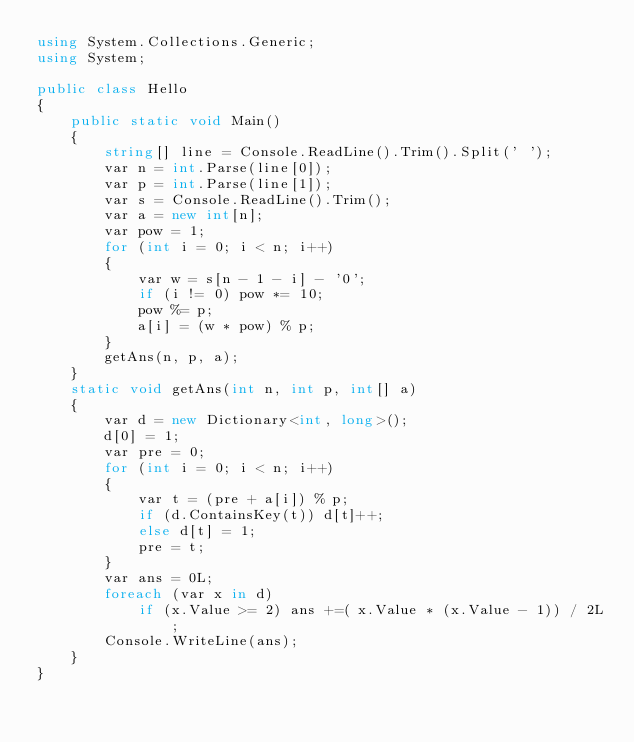Convert code to text. <code><loc_0><loc_0><loc_500><loc_500><_C#_>using System.Collections.Generic;
using System;

public class Hello
{
    public static void Main()
    {
        string[] line = Console.ReadLine().Trim().Split(' ');
        var n = int.Parse(line[0]);
        var p = int.Parse(line[1]);
        var s = Console.ReadLine().Trim();
        var a = new int[n];
        var pow = 1;
        for (int i = 0; i < n; i++)
        {
            var w = s[n - 1 - i] - '0';
            if (i != 0) pow *= 10;
            pow %= p;
            a[i] = (w * pow) % p;
        }
        getAns(n, p, a);
    }
    static void getAns(int n, int p, int[] a)
    {
        var d = new Dictionary<int, long>();
        d[0] = 1;
        var pre = 0;
        for (int i = 0; i < n; i++)
        {
            var t = (pre + a[i]) % p;
            if (d.ContainsKey(t)) d[t]++;
            else d[t] = 1;
            pre = t;
        }
        var ans = 0L;
        foreach (var x in d)
            if (x.Value >= 2) ans +=( x.Value * (x.Value - 1)) / 2L;
        Console.WriteLine(ans);
    }
}
</code> 